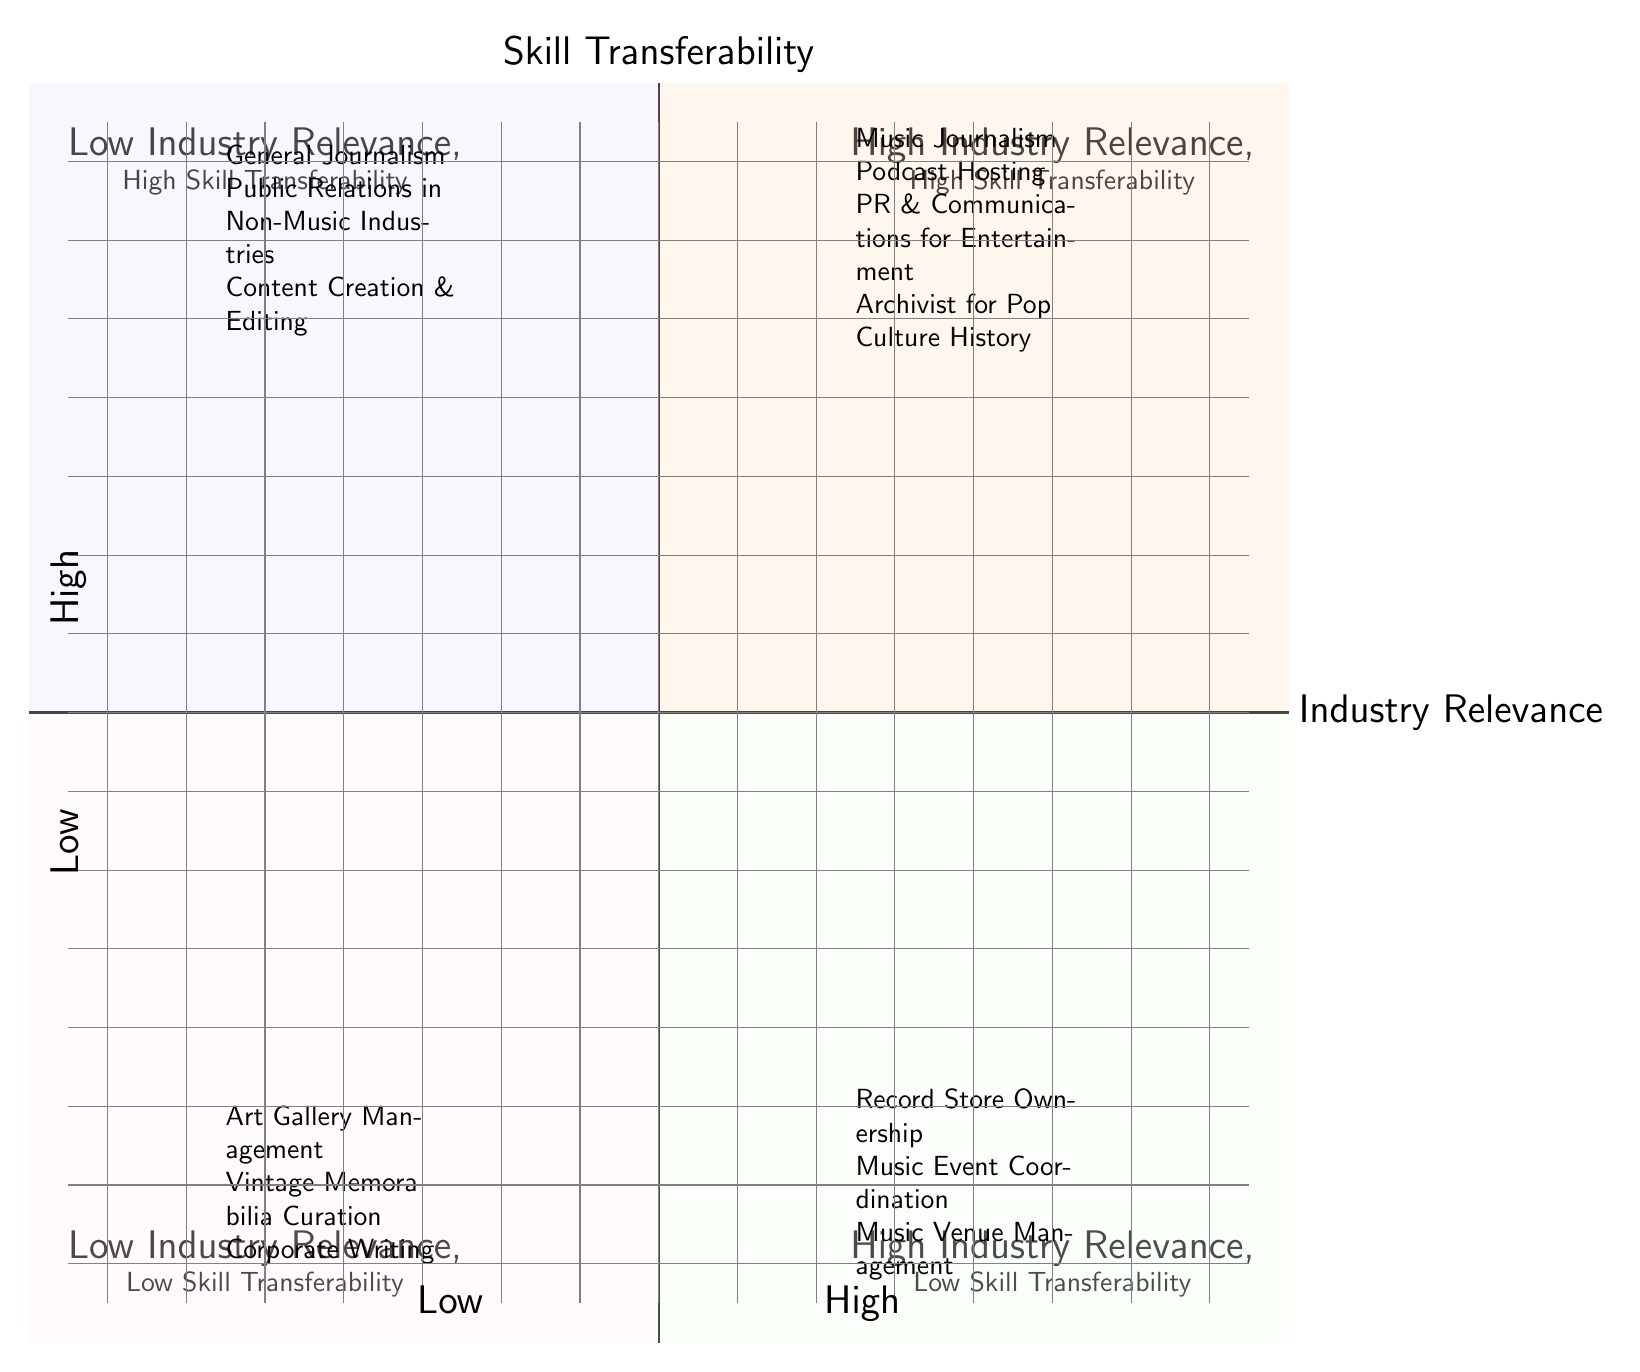What are some examples of roles in the 'High Industry Relevance, High Skill Transferability' quadrant? In the diagram, the 'High Industry Relevance, High Skill Transferability' quadrant includes the roles of Music Journalism, Podcast Hosting, PR & Communications for Entertainment, and Archivist for Pop Culture History.
Answer: Music Journalism, Podcast Hosting, PR & Communications for Entertainment, Archivist for Pop Culture History How many roles are in the 'Low Industry Relevance, Low Skill Transferability' quadrant? By counting the roles listed in the 'Low Industry Relevance, Low Skill Transferability' quadrant, we find three: Art Gallery Management, Vintage Memorabilia Curation, and Corporate Writing.
Answer: 3 Name a role that combines high industry relevance with low skill transferability. From the diagram, 'Record Store Ownership' is listed as a role that has high industry relevance but low skill transferability.
Answer: Record Store Ownership Which quadrant has 'Public Relations in Non-Music Industries' as an example? 'Public Relations in Non-Music Industries' is listed in the 'Low Industry Relevance, High Skill Transferability' quadrant according to the diagram.
Answer: Low Industry Relevance, High Skill Transferability List a role associated with 'Vintage Memorabilia Curation'. The diagram indicates 'Curator at The Smithsonian Institution' as an example role associated with 'Vintage Memorabilia Curation'.
Answer: Curator at The Smithsonian Institution Is 'Music Venue Management' associated with high industry relevance? Yes, 'Music Venue Management' is included in the 'High Industry Relevance, Low Skill Transferability' quadrant, indicating that it has high relevance to the music industry.
Answer: Yes Which two quadrants contain roles related to music? The roles related to music are found in the 'High Industry Relevance, High Skill Transferability' quadrant and the 'High Industry Relevance, Low Skill Transferability' quadrant, indicating both skill transferability and industry relevance.
Answer: High Industry Relevance, High Skill Transferability and High Industry Relevance, Low Skill Transferability What is an example of a position that utilizes skills in general journalism? According to the diagram, a position such as 'Columnist for The New York Times' utilizes skills in general journalism.
Answer: Columnist for The New York Times 